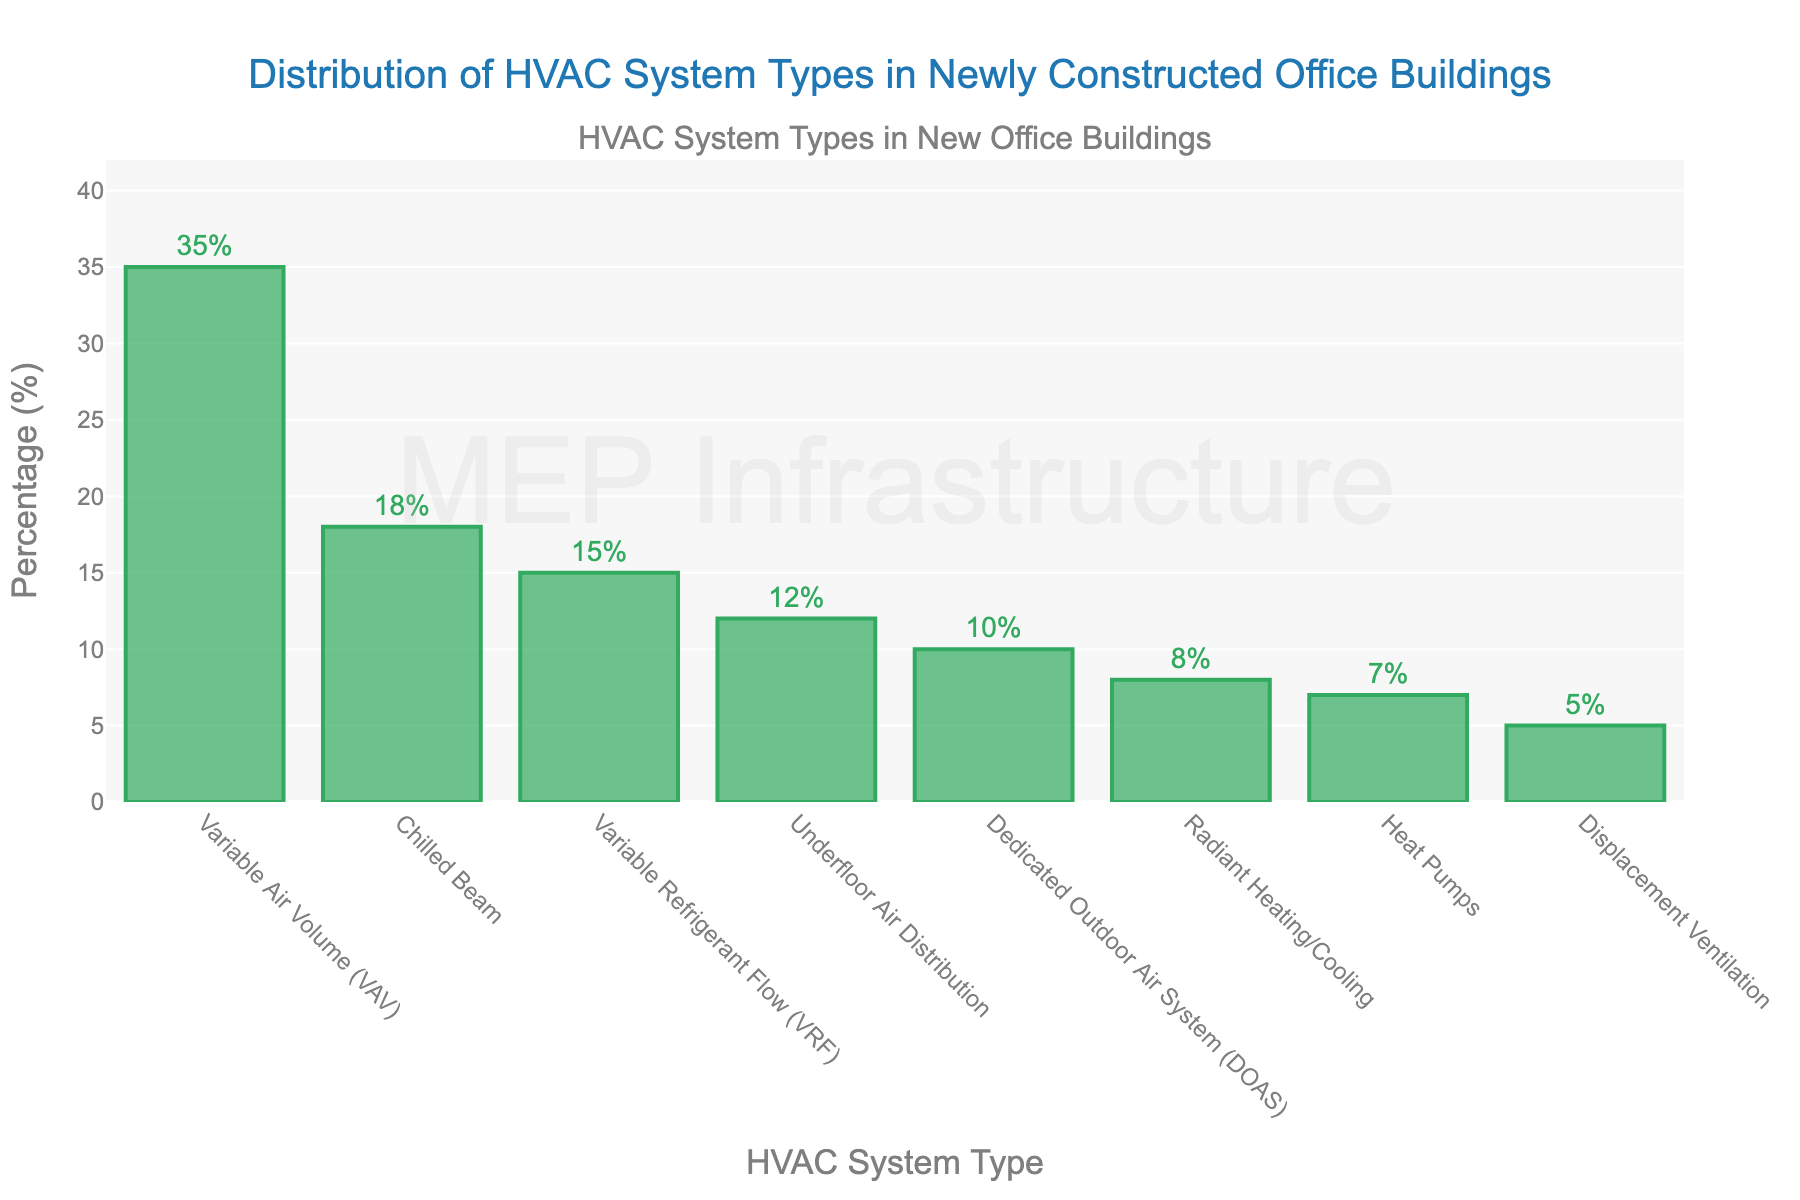What is the most common HVAC system type in newly constructed office buildings? The bar corresponding to the "Variable Air Volume (VAV)" category has the highest percentage, which is 35%.
Answer: Variable Air Volume (VAV) Which HVAC system type is less common, Variable Refrigerant Flow (VRF) or Underfloor Air Distribution? The percentage for Variable Refrigerant Flow (VRF) is 15%, and for Underfloor Air Distribution, it is 12%. Since 12% is less than 15%, Underfloor Air Distribution is less common.
Answer: Underfloor Air Distribution Which HVAC system type has a percentage closest to 10%? The bar corresponding to the "Dedicated Outdoor Air System (DOAS)" category shows a percentage of 10%.
Answer: Dedicated Outdoor Air System (DOAS) What are the percentages for the three least common HVAC system types combined? The three least common HVAC system types and their percentages are: Displacement Ventilation (5%), Radiant Heating/Cooling (8%), and Heat Pumps (7%). Summing these percentages gives 5% + 8% + 7% = 20%.
Answer: 20% How does the percentage of Chilled Beam compare to that of Heat Pumps? The bar for "Chilled Beam" shows a percentage of 18%, while the bar for "Heat Pumps" shows a percentage of 7%. Since 18% is greater than 7%, Chilled Beam has a higher percentage than Heat Pumps.
Answer: Chilled Beam has a higher percentage If the combined percentage of Variable Air Volume (VAV) and Chilled Beam represents 53%, what is the percentage for all other HVAC system types combined? The total percentage is 100%. Subtracting the combined percentage of Variable Air Volume (VAV) and Chilled Beam (53%), we get 100% - 53% = 47%.
Answer: 47% What is the difference in percentage between the most and least common HVAC system types? The most common type "Variable Air Volume (VAV)" has 35%, and the least common type "Displacement Ventilation" has 5%. The difference is 35% - 5% = 30%.
Answer: 30% How many HVAC system types have a percentage greater than 10%? The types with percentages greater than 10% are: Variable Air Volume (VAV) (35%), Chilled Beam (18%), Variable Refrigerant Flow (VRF) (15%), and Underfloor Air Distribution (12%). There are four types.
Answer: 4 